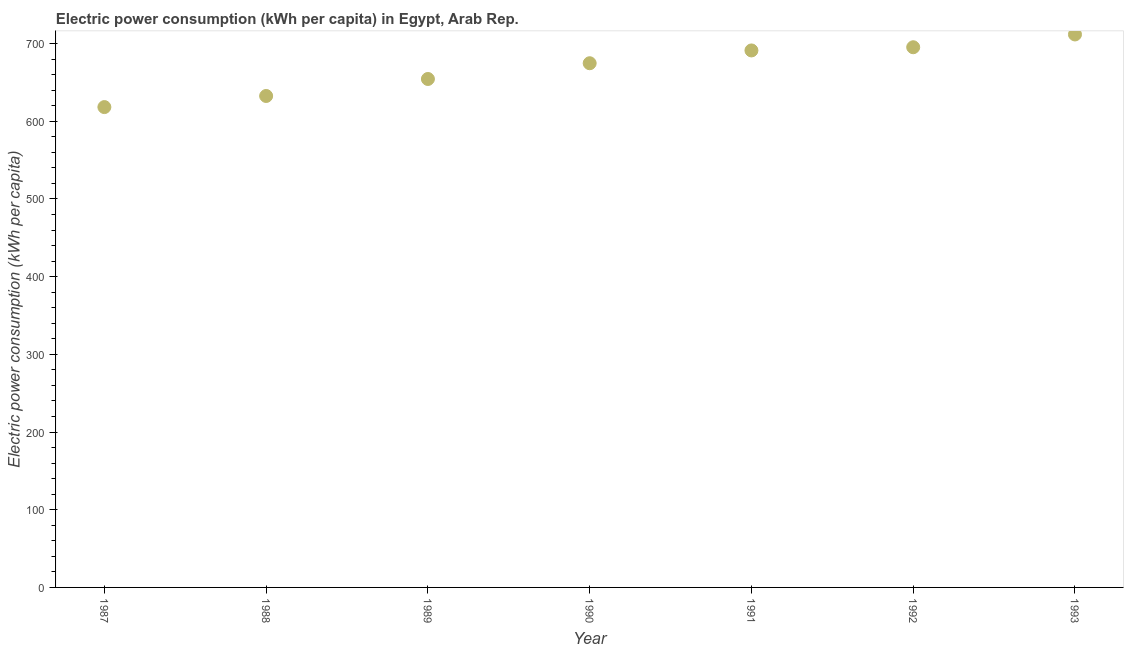What is the electric power consumption in 1992?
Your answer should be compact. 695.24. Across all years, what is the maximum electric power consumption?
Provide a succinct answer. 711.7. Across all years, what is the minimum electric power consumption?
Offer a terse response. 618.22. In which year was the electric power consumption maximum?
Keep it short and to the point. 1993. What is the sum of the electric power consumption?
Your answer should be compact. 4677.85. What is the difference between the electric power consumption in 1991 and 1992?
Provide a succinct answer. -4.11. What is the average electric power consumption per year?
Provide a succinct answer. 668.26. What is the median electric power consumption?
Keep it short and to the point. 674.66. In how many years, is the electric power consumption greater than 400 kWh per capita?
Offer a very short reply. 7. What is the ratio of the electric power consumption in 1989 to that in 1990?
Ensure brevity in your answer.  0.97. Is the electric power consumption in 1987 less than that in 1993?
Offer a very short reply. Yes. Is the difference between the electric power consumption in 1990 and 1993 greater than the difference between any two years?
Offer a very short reply. No. What is the difference between the highest and the second highest electric power consumption?
Make the answer very short. 16.46. Is the sum of the electric power consumption in 1992 and 1993 greater than the maximum electric power consumption across all years?
Keep it short and to the point. Yes. What is the difference between the highest and the lowest electric power consumption?
Your answer should be compact. 93.48. How many dotlines are there?
Give a very brief answer. 1. How many years are there in the graph?
Provide a succinct answer. 7. What is the difference between two consecutive major ticks on the Y-axis?
Provide a succinct answer. 100. Are the values on the major ticks of Y-axis written in scientific E-notation?
Offer a terse response. No. Does the graph contain any zero values?
Make the answer very short. No. What is the title of the graph?
Your response must be concise. Electric power consumption (kWh per capita) in Egypt, Arab Rep. What is the label or title of the X-axis?
Offer a very short reply. Year. What is the label or title of the Y-axis?
Your answer should be compact. Electric power consumption (kWh per capita). What is the Electric power consumption (kWh per capita) in 1987?
Your response must be concise. 618.22. What is the Electric power consumption (kWh per capita) in 1988?
Your response must be concise. 632.52. What is the Electric power consumption (kWh per capita) in 1989?
Give a very brief answer. 654.39. What is the Electric power consumption (kWh per capita) in 1990?
Your answer should be very brief. 674.66. What is the Electric power consumption (kWh per capita) in 1991?
Offer a very short reply. 691.13. What is the Electric power consumption (kWh per capita) in 1992?
Your answer should be compact. 695.24. What is the Electric power consumption (kWh per capita) in 1993?
Keep it short and to the point. 711.7. What is the difference between the Electric power consumption (kWh per capita) in 1987 and 1988?
Your answer should be compact. -14.29. What is the difference between the Electric power consumption (kWh per capita) in 1987 and 1989?
Provide a succinct answer. -36.17. What is the difference between the Electric power consumption (kWh per capita) in 1987 and 1990?
Give a very brief answer. -56.44. What is the difference between the Electric power consumption (kWh per capita) in 1987 and 1991?
Give a very brief answer. -72.91. What is the difference between the Electric power consumption (kWh per capita) in 1987 and 1992?
Your answer should be very brief. -77.02. What is the difference between the Electric power consumption (kWh per capita) in 1987 and 1993?
Make the answer very short. -93.48. What is the difference between the Electric power consumption (kWh per capita) in 1988 and 1989?
Provide a short and direct response. -21.88. What is the difference between the Electric power consumption (kWh per capita) in 1988 and 1990?
Keep it short and to the point. -42.15. What is the difference between the Electric power consumption (kWh per capita) in 1988 and 1991?
Provide a succinct answer. -58.61. What is the difference between the Electric power consumption (kWh per capita) in 1988 and 1992?
Your answer should be compact. -62.73. What is the difference between the Electric power consumption (kWh per capita) in 1988 and 1993?
Your answer should be very brief. -79.18. What is the difference between the Electric power consumption (kWh per capita) in 1989 and 1990?
Make the answer very short. -20.27. What is the difference between the Electric power consumption (kWh per capita) in 1989 and 1991?
Your response must be concise. -36.74. What is the difference between the Electric power consumption (kWh per capita) in 1989 and 1992?
Provide a short and direct response. -40.85. What is the difference between the Electric power consumption (kWh per capita) in 1989 and 1993?
Offer a terse response. -57.31. What is the difference between the Electric power consumption (kWh per capita) in 1990 and 1991?
Your answer should be compact. -16.47. What is the difference between the Electric power consumption (kWh per capita) in 1990 and 1992?
Give a very brief answer. -20.58. What is the difference between the Electric power consumption (kWh per capita) in 1990 and 1993?
Provide a succinct answer. -37.04. What is the difference between the Electric power consumption (kWh per capita) in 1991 and 1992?
Keep it short and to the point. -4.11. What is the difference between the Electric power consumption (kWh per capita) in 1991 and 1993?
Your response must be concise. -20.57. What is the difference between the Electric power consumption (kWh per capita) in 1992 and 1993?
Make the answer very short. -16.46. What is the ratio of the Electric power consumption (kWh per capita) in 1987 to that in 1988?
Your response must be concise. 0.98. What is the ratio of the Electric power consumption (kWh per capita) in 1987 to that in 1989?
Keep it short and to the point. 0.94. What is the ratio of the Electric power consumption (kWh per capita) in 1987 to that in 1990?
Keep it short and to the point. 0.92. What is the ratio of the Electric power consumption (kWh per capita) in 1987 to that in 1991?
Ensure brevity in your answer.  0.9. What is the ratio of the Electric power consumption (kWh per capita) in 1987 to that in 1992?
Offer a terse response. 0.89. What is the ratio of the Electric power consumption (kWh per capita) in 1987 to that in 1993?
Provide a succinct answer. 0.87. What is the ratio of the Electric power consumption (kWh per capita) in 1988 to that in 1989?
Give a very brief answer. 0.97. What is the ratio of the Electric power consumption (kWh per capita) in 1988 to that in 1990?
Provide a succinct answer. 0.94. What is the ratio of the Electric power consumption (kWh per capita) in 1988 to that in 1991?
Your answer should be very brief. 0.92. What is the ratio of the Electric power consumption (kWh per capita) in 1988 to that in 1992?
Ensure brevity in your answer.  0.91. What is the ratio of the Electric power consumption (kWh per capita) in 1988 to that in 1993?
Make the answer very short. 0.89. What is the ratio of the Electric power consumption (kWh per capita) in 1989 to that in 1990?
Make the answer very short. 0.97. What is the ratio of the Electric power consumption (kWh per capita) in 1989 to that in 1991?
Ensure brevity in your answer.  0.95. What is the ratio of the Electric power consumption (kWh per capita) in 1989 to that in 1992?
Your answer should be very brief. 0.94. What is the ratio of the Electric power consumption (kWh per capita) in 1989 to that in 1993?
Ensure brevity in your answer.  0.92. What is the ratio of the Electric power consumption (kWh per capita) in 1990 to that in 1992?
Give a very brief answer. 0.97. What is the ratio of the Electric power consumption (kWh per capita) in 1990 to that in 1993?
Make the answer very short. 0.95. What is the ratio of the Electric power consumption (kWh per capita) in 1991 to that in 1993?
Keep it short and to the point. 0.97. What is the ratio of the Electric power consumption (kWh per capita) in 1992 to that in 1993?
Your answer should be compact. 0.98. 